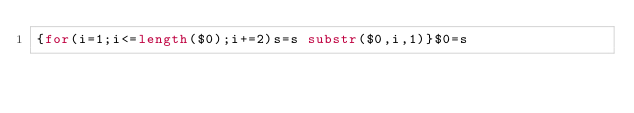Convert code to text. <code><loc_0><loc_0><loc_500><loc_500><_Awk_>{for(i=1;i<=length($0);i+=2)s=s substr($0,i,1)}$0=s</code> 